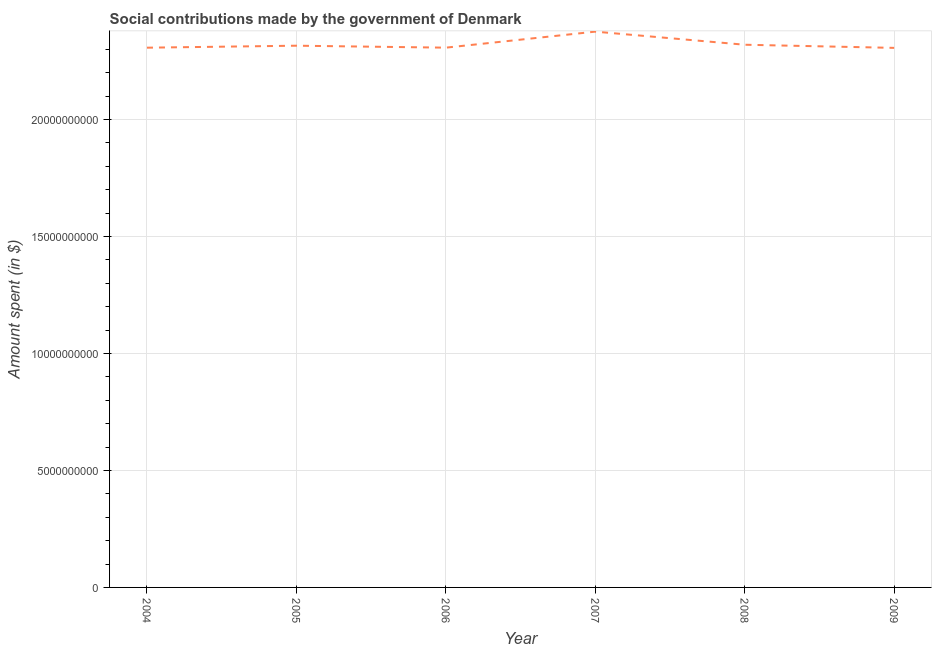What is the amount spent in making social contributions in 2007?
Offer a very short reply. 2.38e+1. Across all years, what is the maximum amount spent in making social contributions?
Offer a terse response. 2.38e+1. Across all years, what is the minimum amount spent in making social contributions?
Your answer should be very brief. 2.31e+1. What is the sum of the amount spent in making social contributions?
Your response must be concise. 1.39e+11. What is the difference between the amount spent in making social contributions in 2007 and 2008?
Provide a short and direct response. 5.60e+08. What is the average amount spent in making social contributions per year?
Give a very brief answer. 2.32e+1. What is the median amount spent in making social contributions?
Make the answer very short. 2.31e+1. In how many years, is the amount spent in making social contributions greater than 22000000000 $?
Provide a succinct answer. 6. Do a majority of the years between 2004 and 2005 (inclusive) have amount spent in making social contributions greater than 18000000000 $?
Offer a terse response. Yes. What is the ratio of the amount spent in making social contributions in 2007 to that in 2009?
Offer a terse response. 1.03. What is the difference between the highest and the second highest amount spent in making social contributions?
Your response must be concise. 5.60e+08. What is the difference between the highest and the lowest amount spent in making social contributions?
Ensure brevity in your answer.  6.94e+08. How many years are there in the graph?
Ensure brevity in your answer.  6. What is the difference between two consecutive major ticks on the Y-axis?
Ensure brevity in your answer.  5.00e+09. Are the values on the major ticks of Y-axis written in scientific E-notation?
Your answer should be compact. No. What is the title of the graph?
Provide a short and direct response. Social contributions made by the government of Denmark. What is the label or title of the X-axis?
Your answer should be compact. Year. What is the label or title of the Y-axis?
Give a very brief answer. Amount spent (in $). What is the Amount spent (in $) of 2004?
Offer a terse response. 2.31e+1. What is the Amount spent (in $) of 2005?
Ensure brevity in your answer.  2.32e+1. What is the Amount spent (in $) of 2006?
Provide a succinct answer. 2.31e+1. What is the Amount spent (in $) of 2007?
Provide a succinct answer. 2.38e+1. What is the Amount spent (in $) in 2008?
Give a very brief answer. 2.32e+1. What is the Amount spent (in $) in 2009?
Your answer should be compact. 2.31e+1. What is the difference between the Amount spent (in $) in 2004 and 2005?
Offer a terse response. -8.50e+07. What is the difference between the Amount spent (in $) in 2004 and 2007?
Offer a very short reply. -6.86e+08. What is the difference between the Amount spent (in $) in 2004 and 2008?
Offer a very short reply. -1.26e+08. What is the difference between the Amount spent (in $) in 2005 and 2006?
Offer a terse response. 8.40e+07. What is the difference between the Amount spent (in $) in 2005 and 2007?
Ensure brevity in your answer.  -6.01e+08. What is the difference between the Amount spent (in $) in 2005 and 2008?
Give a very brief answer. -4.10e+07. What is the difference between the Amount spent (in $) in 2005 and 2009?
Provide a short and direct response. 9.30e+07. What is the difference between the Amount spent (in $) in 2006 and 2007?
Your answer should be very brief. -6.85e+08. What is the difference between the Amount spent (in $) in 2006 and 2008?
Your answer should be compact. -1.25e+08. What is the difference between the Amount spent (in $) in 2006 and 2009?
Make the answer very short. 9.00e+06. What is the difference between the Amount spent (in $) in 2007 and 2008?
Provide a succinct answer. 5.60e+08. What is the difference between the Amount spent (in $) in 2007 and 2009?
Provide a succinct answer. 6.94e+08. What is the difference between the Amount spent (in $) in 2008 and 2009?
Offer a terse response. 1.34e+08. What is the ratio of the Amount spent (in $) in 2004 to that in 2005?
Provide a short and direct response. 1. What is the ratio of the Amount spent (in $) in 2004 to that in 2006?
Give a very brief answer. 1. What is the ratio of the Amount spent (in $) in 2004 to that in 2007?
Make the answer very short. 0.97. What is the ratio of the Amount spent (in $) in 2004 to that in 2009?
Ensure brevity in your answer.  1. What is the ratio of the Amount spent (in $) in 2005 to that in 2006?
Your answer should be very brief. 1. What is the ratio of the Amount spent (in $) in 2006 to that in 2007?
Offer a terse response. 0.97. What is the ratio of the Amount spent (in $) in 2006 to that in 2008?
Your response must be concise. 0.99. What is the ratio of the Amount spent (in $) in 2006 to that in 2009?
Provide a succinct answer. 1. What is the ratio of the Amount spent (in $) in 2007 to that in 2009?
Your response must be concise. 1.03. 